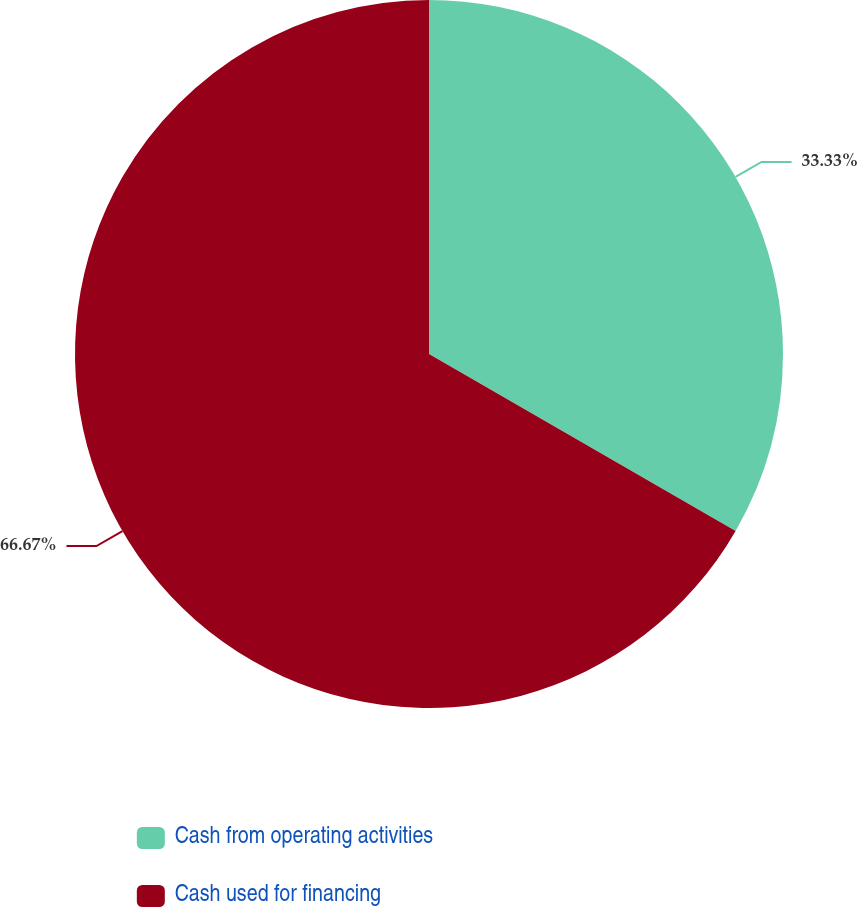Convert chart. <chart><loc_0><loc_0><loc_500><loc_500><pie_chart><fcel>Cash from operating activities<fcel>Cash used for financing<nl><fcel>33.33%<fcel>66.67%<nl></chart> 